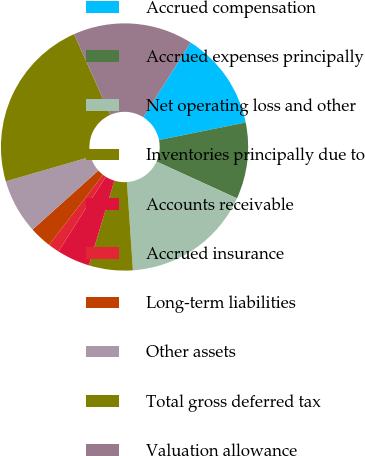<chart> <loc_0><loc_0><loc_500><loc_500><pie_chart><fcel>Accrued compensation<fcel>Accrued expenses principally<fcel>Net operating loss and other<fcel>Inventories principally due to<fcel>Accounts receivable<fcel>Accrued insurance<fcel>Long-term liabilities<fcel>Other assets<fcel>Total gross deferred tax<fcel>Valuation allowance<nl><fcel>12.84%<fcel>10.0%<fcel>17.1%<fcel>5.74%<fcel>4.32%<fcel>1.48%<fcel>2.9%<fcel>7.16%<fcel>22.79%<fcel>15.68%<nl></chart> 